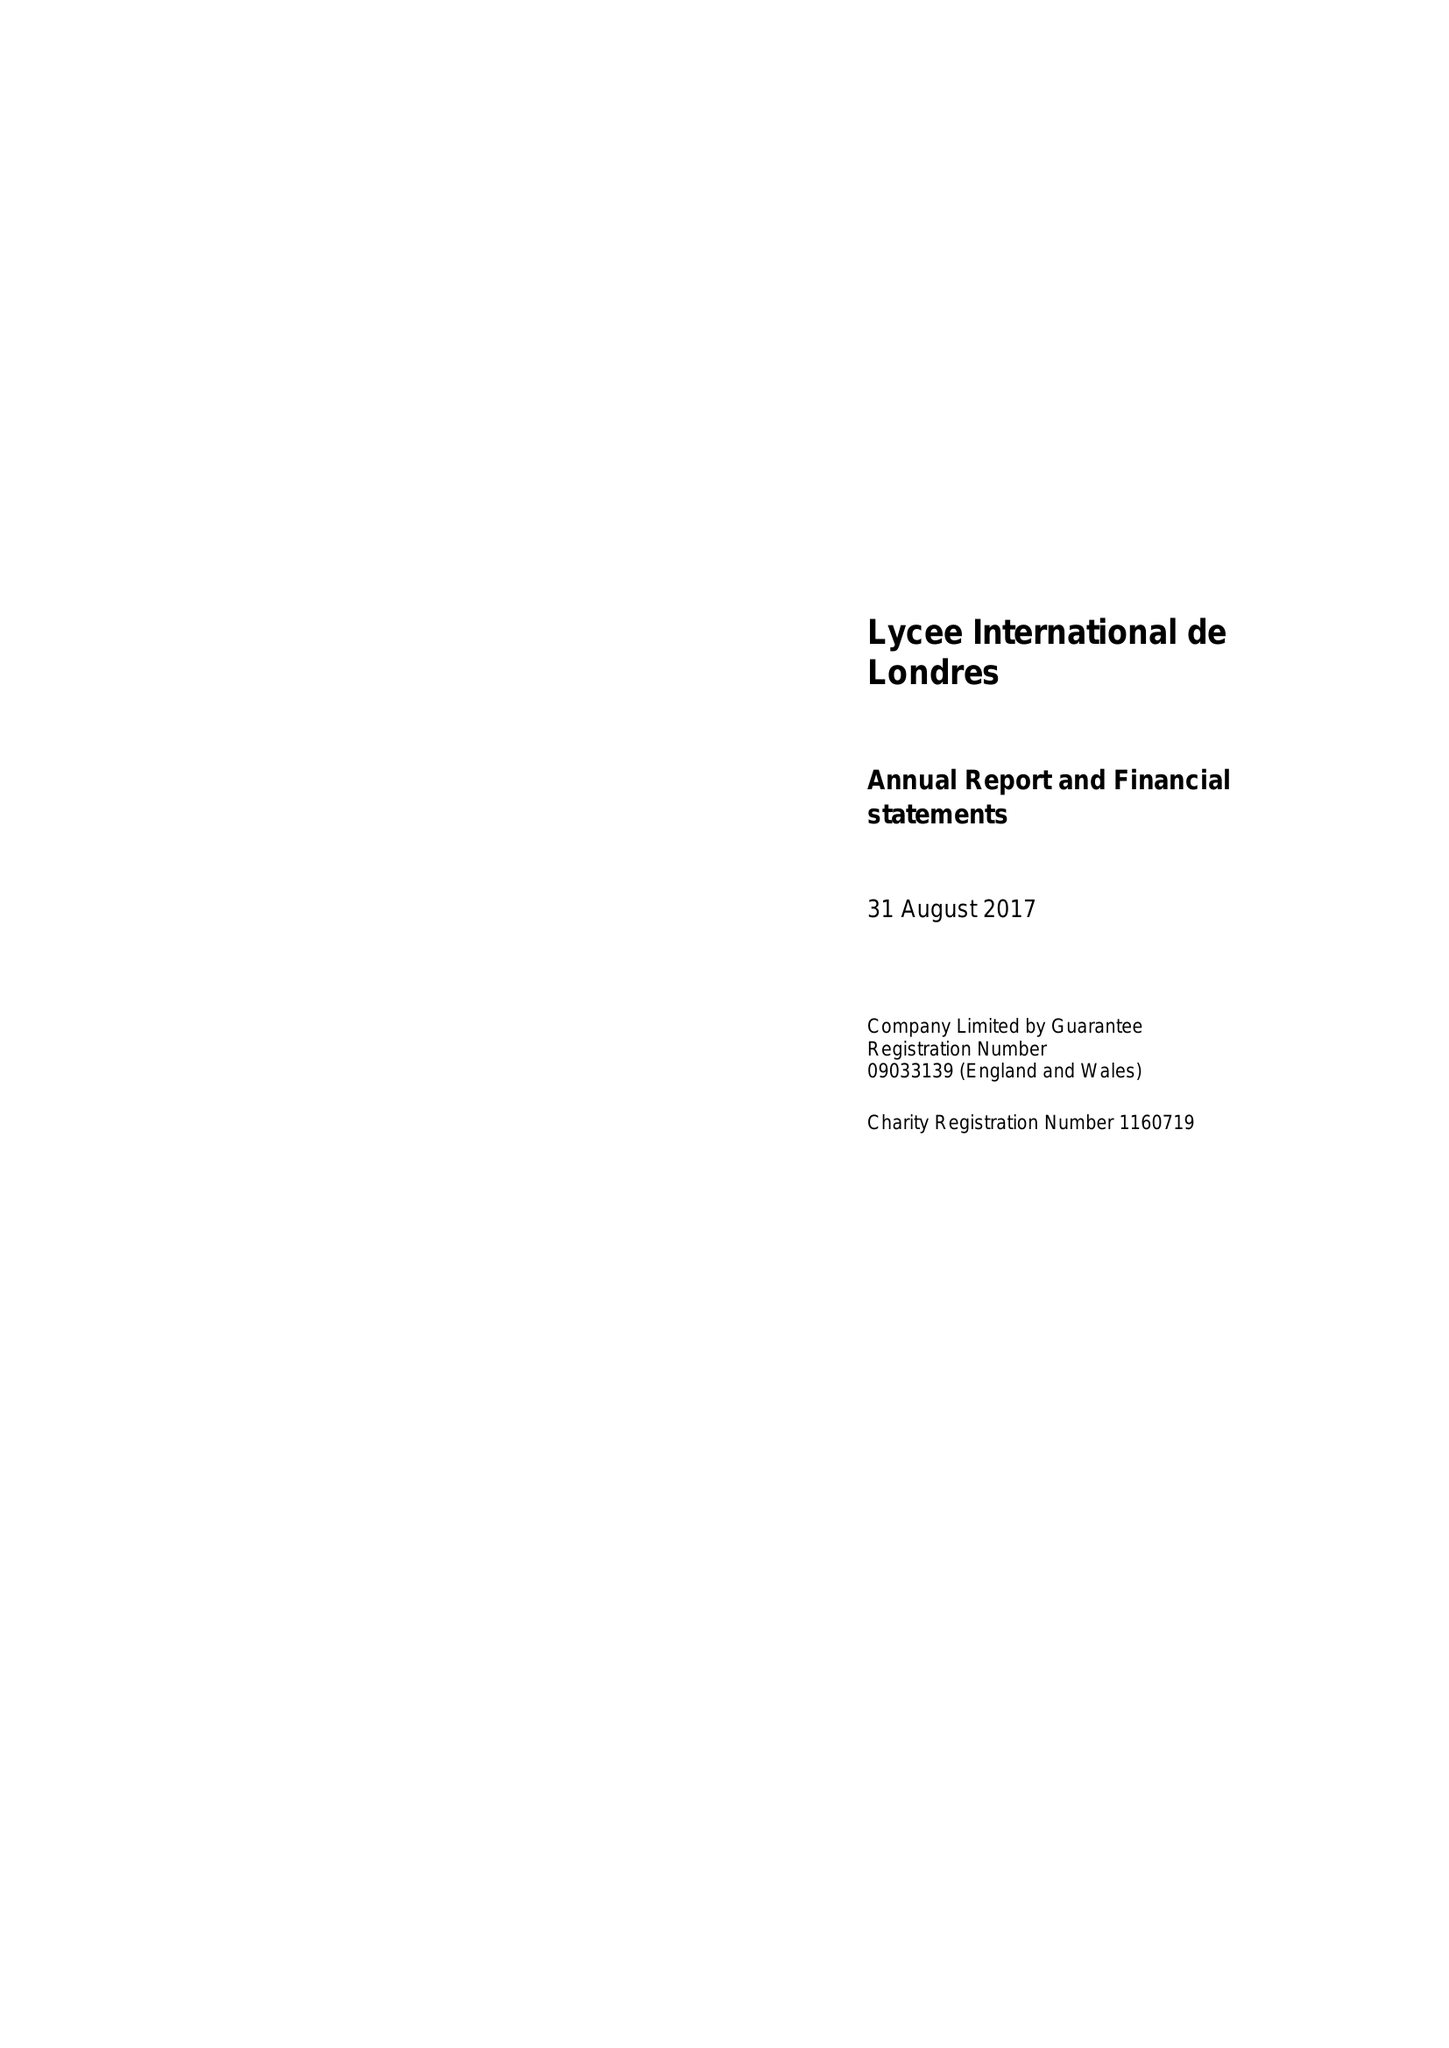What is the value for the spending_annually_in_british_pounds?
Answer the question using a single word or phrase. 8686025.00 